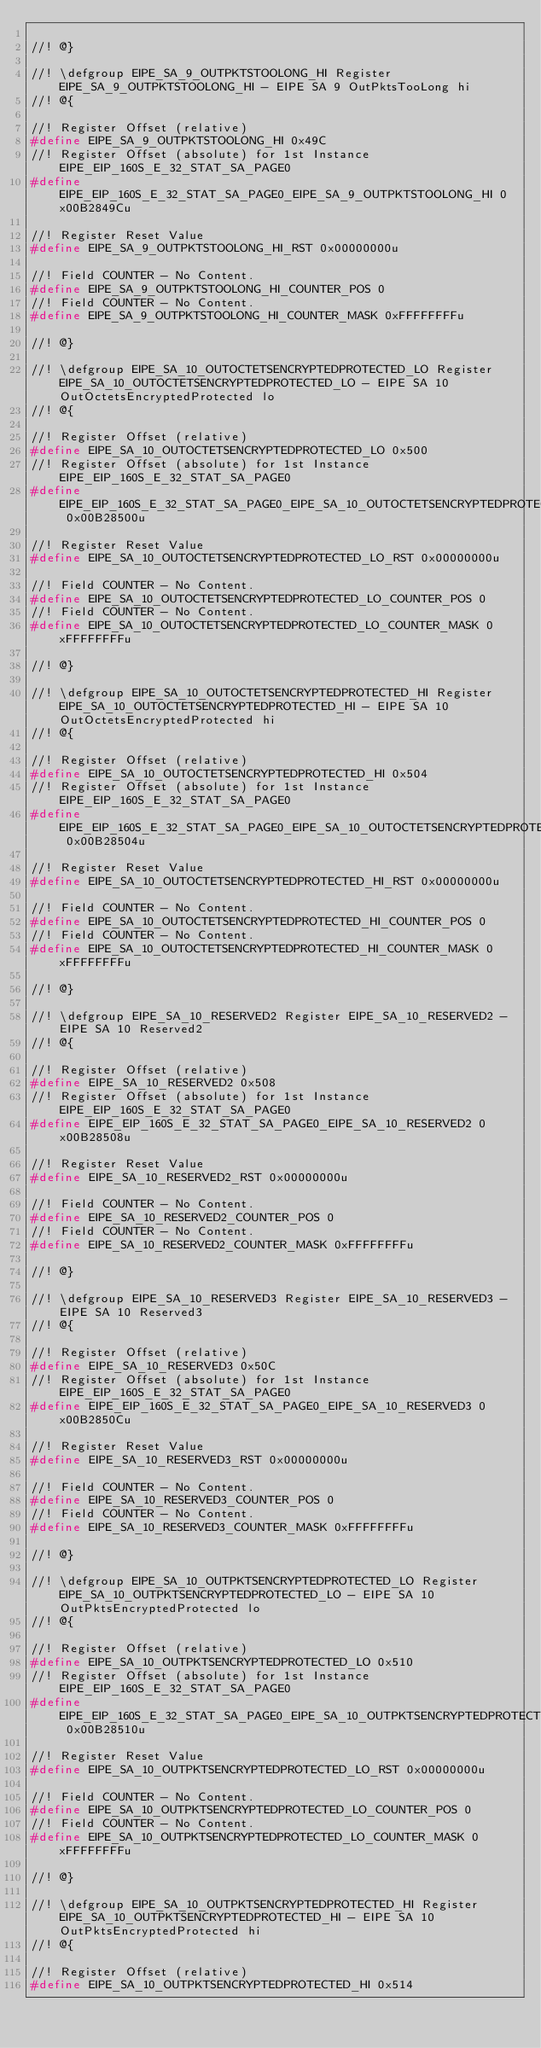Convert code to text. <code><loc_0><loc_0><loc_500><loc_500><_C_>
//! @}

//! \defgroup EIPE_SA_9_OUTPKTSTOOLONG_HI Register EIPE_SA_9_OUTPKTSTOOLONG_HI - EIPE SA 9 OutPktsTooLong hi
//! @{

//! Register Offset (relative)
#define EIPE_SA_9_OUTPKTSTOOLONG_HI 0x49C
//! Register Offset (absolute) for 1st Instance EIPE_EIP_160S_E_32_STAT_SA_PAGE0
#define EIPE_EIP_160S_E_32_STAT_SA_PAGE0_EIPE_SA_9_OUTPKTSTOOLONG_HI 0x00B2849Cu

//! Register Reset Value
#define EIPE_SA_9_OUTPKTSTOOLONG_HI_RST 0x00000000u

//! Field COUNTER - No Content.
#define EIPE_SA_9_OUTPKTSTOOLONG_HI_COUNTER_POS 0
//! Field COUNTER - No Content.
#define EIPE_SA_9_OUTPKTSTOOLONG_HI_COUNTER_MASK 0xFFFFFFFFu

//! @}

//! \defgroup EIPE_SA_10_OUTOCTETSENCRYPTEDPROTECTED_LO Register EIPE_SA_10_OUTOCTETSENCRYPTEDPROTECTED_LO - EIPE SA 10 OutOctetsEncryptedProtected lo
//! @{

//! Register Offset (relative)
#define EIPE_SA_10_OUTOCTETSENCRYPTEDPROTECTED_LO 0x500
//! Register Offset (absolute) for 1st Instance EIPE_EIP_160S_E_32_STAT_SA_PAGE0
#define EIPE_EIP_160S_E_32_STAT_SA_PAGE0_EIPE_SA_10_OUTOCTETSENCRYPTEDPROTECTED_LO 0x00B28500u

//! Register Reset Value
#define EIPE_SA_10_OUTOCTETSENCRYPTEDPROTECTED_LO_RST 0x00000000u

//! Field COUNTER - No Content.
#define EIPE_SA_10_OUTOCTETSENCRYPTEDPROTECTED_LO_COUNTER_POS 0
//! Field COUNTER - No Content.
#define EIPE_SA_10_OUTOCTETSENCRYPTEDPROTECTED_LO_COUNTER_MASK 0xFFFFFFFFu

//! @}

//! \defgroup EIPE_SA_10_OUTOCTETSENCRYPTEDPROTECTED_HI Register EIPE_SA_10_OUTOCTETSENCRYPTEDPROTECTED_HI - EIPE SA 10 OutOctetsEncryptedProtected hi
//! @{

//! Register Offset (relative)
#define EIPE_SA_10_OUTOCTETSENCRYPTEDPROTECTED_HI 0x504
//! Register Offset (absolute) for 1st Instance EIPE_EIP_160S_E_32_STAT_SA_PAGE0
#define EIPE_EIP_160S_E_32_STAT_SA_PAGE0_EIPE_SA_10_OUTOCTETSENCRYPTEDPROTECTED_HI 0x00B28504u

//! Register Reset Value
#define EIPE_SA_10_OUTOCTETSENCRYPTEDPROTECTED_HI_RST 0x00000000u

//! Field COUNTER - No Content.
#define EIPE_SA_10_OUTOCTETSENCRYPTEDPROTECTED_HI_COUNTER_POS 0
//! Field COUNTER - No Content.
#define EIPE_SA_10_OUTOCTETSENCRYPTEDPROTECTED_HI_COUNTER_MASK 0xFFFFFFFFu

//! @}

//! \defgroup EIPE_SA_10_RESERVED2 Register EIPE_SA_10_RESERVED2 - EIPE SA 10 Reserved2
//! @{

//! Register Offset (relative)
#define EIPE_SA_10_RESERVED2 0x508
//! Register Offset (absolute) for 1st Instance EIPE_EIP_160S_E_32_STAT_SA_PAGE0
#define EIPE_EIP_160S_E_32_STAT_SA_PAGE0_EIPE_SA_10_RESERVED2 0x00B28508u

//! Register Reset Value
#define EIPE_SA_10_RESERVED2_RST 0x00000000u

//! Field COUNTER - No Content.
#define EIPE_SA_10_RESERVED2_COUNTER_POS 0
//! Field COUNTER - No Content.
#define EIPE_SA_10_RESERVED2_COUNTER_MASK 0xFFFFFFFFu

//! @}

//! \defgroup EIPE_SA_10_RESERVED3 Register EIPE_SA_10_RESERVED3 - EIPE SA 10 Reserved3
//! @{

//! Register Offset (relative)
#define EIPE_SA_10_RESERVED3 0x50C
//! Register Offset (absolute) for 1st Instance EIPE_EIP_160S_E_32_STAT_SA_PAGE0
#define EIPE_EIP_160S_E_32_STAT_SA_PAGE0_EIPE_SA_10_RESERVED3 0x00B2850Cu

//! Register Reset Value
#define EIPE_SA_10_RESERVED3_RST 0x00000000u

//! Field COUNTER - No Content.
#define EIPE_SA_10_RESERVED3_COUNTER_POS 0
//! Field COUNTER - No Content.
#define EIPE_SA_10_RESERVED3_COUNTER_MASK 0xFFFFFFFFu

//! @}

//! \defgroup EIPE_SA_10_OUTPKTSENCRYPTEDPROTECTED_LO Register EIPE_SA_10_OUTPKTSENCRYPTEDPROTECTED_LO - EIPE SA 10 OutPktsEncryptedProtected lo
//! @{

//! Register Offset (relative)
#define EIPE_SA_10_OUTPKTSENCRYPTEDPROTECTED_LO 0x510
//! Register Offset (absolute) for 1st Instance EIPE_EIP_160S_E_32_STAT_SA_PAGE0
#define EIPE_EIP_160S_E_32_STAT_SA_PAGE0_EIPE_SA_10_OUTPKTSENCRYPTEDPROTECTED_LO 0x00B28510u

//! Register Reset Value
#define EIPE_SA_10_OUTPKTSENCRYPTEDPROTECTED_LO_RST 0x00000000u

//! Field COUNTER - No Content.
#define EIPE_SA_10_OUTPKTSENCRYPTEDPROTECTED_LO_COUNTER_POS 0
//! Field COUNTER - No Content.
#define EIPE_SA_10_OUTPKTSENCRYPTEDPROTECTED_LO_COUNTER_MASK 0xFFFFFFFFu

//! @}

//! \defgroup EIPE_SA_10_OUTPKTSENCRYPTEDPROTECTED_HI Register EIPE_SA_10_OUTPKTSENCRYPTEDPROTECTED_HI - EIPE SA 10 OutPktsEncryptedProtected hi
//! @{

//! Register Offset (relative)
#define EIPE_SA_10_OUTPKTSENCRYPTEDPROTECTED_HI 0x514</code> 